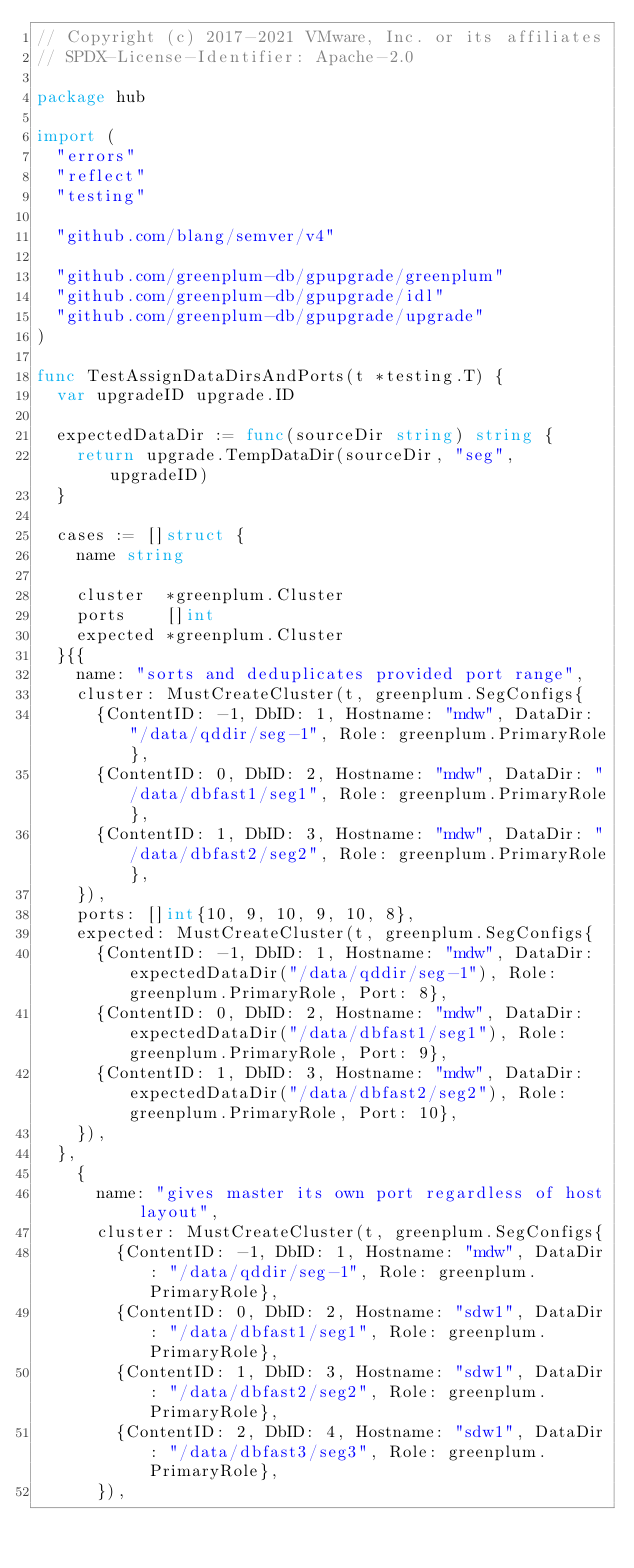Convert code to text. <code><loc_0><loc_0><loc_500><loc_500><_Go_>// Copyright (c) 2017-2021 VMware, Inc. or its affiliates
// SPDX-License-Identifier: Apache-2.0

package hub

import (
	"errors"
	"reflect"
	"testing"

	"github.com/blang/semver/v4"

	"github.com/greenplum-db/gpupgrade/greenplum"
	"github.com/greenplum-db/gpupgrade/idl"
	"github.com/greenplum-db/gpupgrade/upgrade"
)

func TestAssignDataDirsAndPorts(t *testing.T) {
	var upgradeID upgrade.ID

	expectedDataDir := func(sourceDir string) string {
		return upgrade.TempDataDir(sourceDir, "seg", upgradeID)
	}

	cases := []struct {
		name string

		cluster  *greenplum.Cluster
		ports    []int
		expected *greenplum.Cluster
	}{{
		name: "sorts and deduplicates provided port range",
		cluster: MustCreateCluster(t, greenplum.SegConfigs{
			{ContentID: -1, DbID: 1, Hostname: "mdw", DataDir: "/data/qddir/seg-1", Role: greenplum.PrimaryRole},
			{ContentID: 0, DbID: 2, Hostname: "mdw", DataDir: "/data/dbfast1/seg1", Role: greenplum.PrimaryRole},
			{ContentID: 1, DbID: 3, Hostname: "mdw", DataDir: "/data/dbfast2/seg2", Role: greenplum.PrimaryRole},
		}),
		ports: []int{10, 9, 10, 9, 10, 8},
		expected: MustCreateCluster(t, greenplum.SegConfigs{
			{ContentID: -1, DbID: 1, Hostname: "mdw", DataDir: expectedDataDir("/data/qddir/seg-1"), Role: greenplum.PrimaryRole, Port: 8},
			{ContentID: 0, DbID: 2, Hostname: "mdw", DataDir: expectedDataDir("/data/dbfast1/seg1"), Role: greenplum.PrimaryRole, Port: 9},
			{ContentID: 1, DbID: 3, Hostname: "mdw", DataDir: expectedDataDir("/data/dbfast2/seg2"), Role: greenplum.PrimaryRole, Port: 10},
		}),
	},
		{
			name: "gives master its own port regardless of host layout",
			cluster: MustCreateCluster(t, greenplum.SegConfigs{
				{ContentID: -1, DbID: 1, Hostname: "mdw", DataDir: "/data/qddir/seg-1", Role: greenplum.PrimaryRole},
				{ContentID: 0, DbID: 2, Hostname: "sdw1", DataDir: "/data/dbfast1/seg1", Role: greenplum.PrimaryRole},
				{ContentID: 1, DbID: 3, Hostname: "sdw1", DataDir: "/data/dbfast2/seg2", Role: greenplum.PrimaryRole},
				{ContentID: 2, DbID: 4, Hostname: "sdw1", DataDir: "/data/dbfast3/seg3", Role: greenplum.PrimaryRole},
			}),</code> 